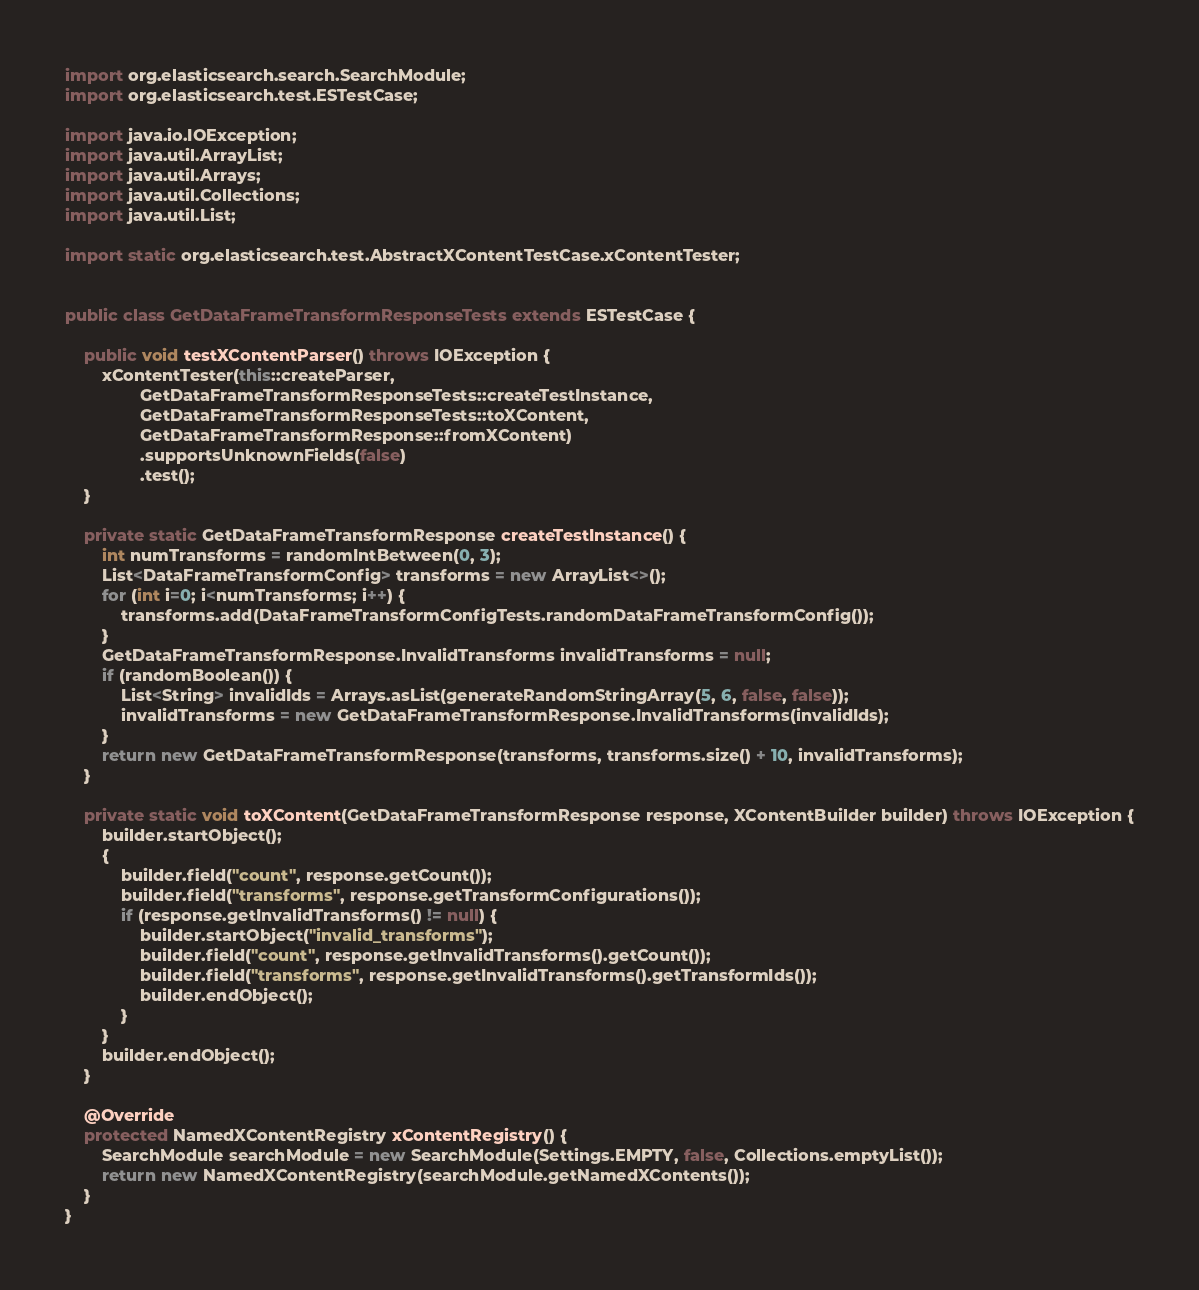Convert code to text. <code><loc_0><loc_0><loc_500><loc_500><_Java_>import org.elasticsearch.search.SearchModule;
import org.elasticsearch.test.ESTestCase;

import java.io.IOException;
import java.util.ArrayList;
import java.util.Arrays;
import java.util.Collections;
import java.util.List;

import static org.elasticsearch.test.AbstractXContentTestCase.xContentTester;


public class GetDataFrameTransformResponseTests extends ESTestCase {

    public void testXContentParser() throws IOException {
        xContentTester(this::createParser,
                GetDataFrameTransformResponseTests::createTestInstance,
                GetDataFrameTransformResponseTests::toXContent,
                GetDataFrameTransformResponse::fromXContent)
                .supportsUnknownFields(false)
                .test();
    }

    private static GetDataFrameTransformResponse createTestInstance() {
        int numTransforms = randomIntBetween(0, 3);
        List<DataFrameTransformConfig> transforms = new ArrayList<>();
        for (int i=0; i<numTransforms; i++) {
            transforms.add(DataFrameTransformConfigTests.randomDataFrameTransformConfig());
        }
        GetDataFrameTransformResponse.InvalidTransforms invalidTransforms = null;
        if (randomBoolean()) {
            List<String> invalidIds = Arrays.asList(generateRandomStringArray(5, 6, false, false));
            invalidTransforms = new GetDataFrameTransformResponse.InvalidTransforms(invalidIds);
        }
        return new GetDataFrameTransformResponse(transforms, transforms.size() + 10, invalidTransforms);
    }

    private static void toXContent(GetDataFrameTransformResponse response, XContentBuilder builder) throws IOException {
        builder.startObject();
        {
            builder.field("count", response.getCount());
            builder.field("transforms", response.getTransformConfigurations());
            if (response.getInvalidTransforms() != null) {
                builder.startObject("invalid_transforms");
                builder.field("count", response.getInvalidTransforms().getCount());
                builder.field("transforms", response.getInvalidTransforms().getTransformIds());
                builder.endObject();
            }
        }
        builder.endObject();
    }

    @Override
    protected NamedXContentRegistry xContentRegistry() {
        SearchModule searchModule = new SearchModule(Settings.EMPTY, false, Collections.emptyList());
        return new NamedXContentRegistry(searchModule.getNamedXContents());
    }
}
</code> 